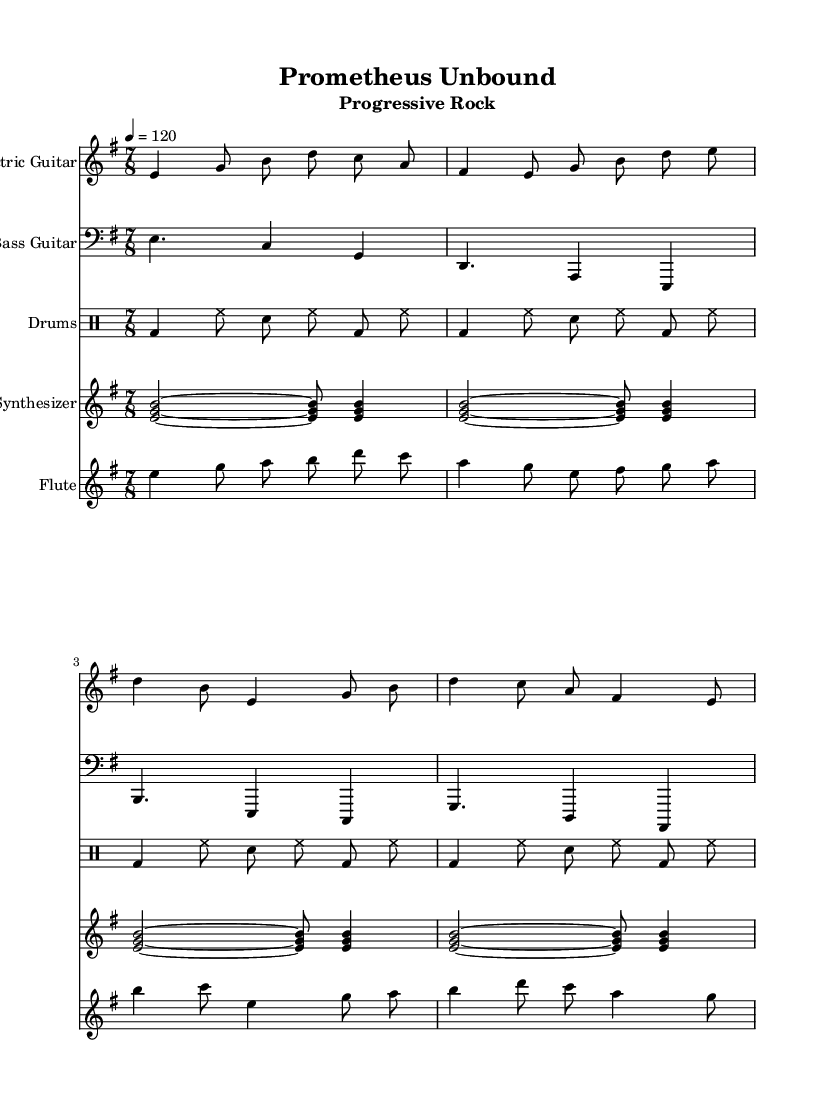What is the key signature of this music? The key signature is E minor, which has one sharp (F#). This can be identified by looking at the key signature indicated at the beginning of the staff.
Answer: E minor What is the time signature used in this piece? The time signature is 7/8, as shown at the beginning of the music. This indicates that there are seven eighth notes per measure.
Answer: 7/8 What is the tempo marking for this score? The tempo marking is 4 equals 120. This indicates that there are 120 beats per minute and each beat is a quarter note.
Answer: 120 Which instrument is playing the melody in this segment? The flute is primarily playing the melody in the provided segments, as indicated by the notated notes and instrument name at the beginning of the staff for flute.
Answer: Flute How many measures are played by the electric guitar before the first repeated section? The electric guitar plays four measures before the first repeated section, which can be determined by counting the measures in the notated part of the music before any duplications.
Answer: 4 What is the rhythmic pattern used for the drums? The rhythmic pattern consists of a bass drum, hi-hat, and snare on alternating eighth notes, creating a consistent driving rhythm typical in rock music. This is evident in the drummode notation.
Answer: Bass drum and hi-hat What type of musical influence does the title "Prometheus Unbound" suggest? The title suggests influence from Greek mythology, referencing the Titan who stole fire from the gods. This indicates a thematic connection to ancient myths in the context of progressive rock music.
Answer: Greek mythology 